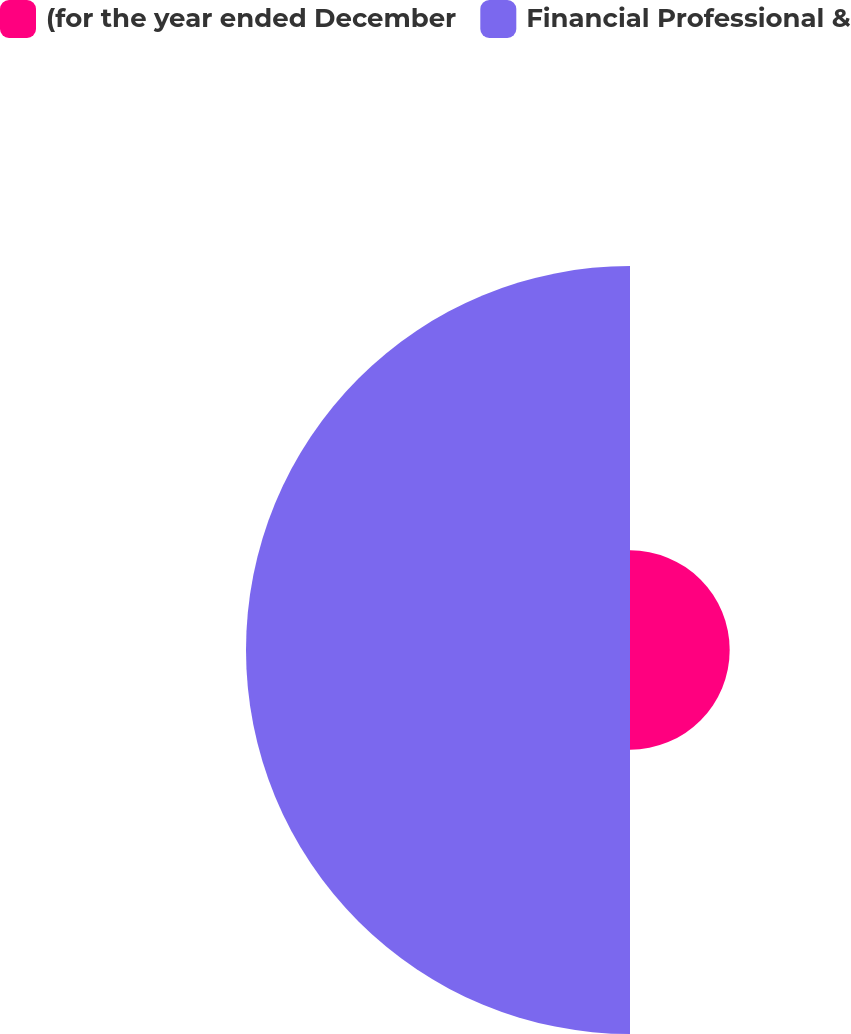Convert chart to OTSL. <chart><loc_0><loc_0><loc_500><loc_500><pie_chart><fcel>(for the year ended December<fcel>Financial Professional &<nl><fcel>20.61%<fcel>79.39%<nl></chart> 